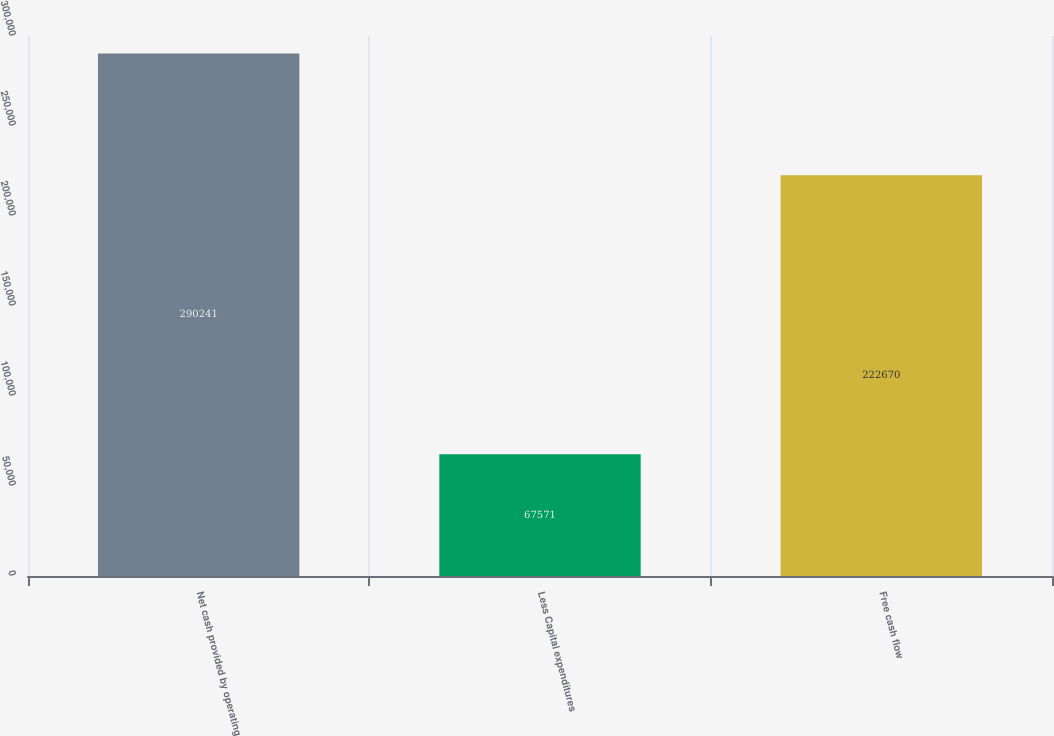Convert chart. <chart><loc_0><loc_0><loc_500><loc_500><bar_chart><fcel>Net cash provided by operating<fcel>Less Capital expenditures<fcel>Free cash flow<nl><fcel>290241<fcel>67571<fcel>222670<nl></chart> 